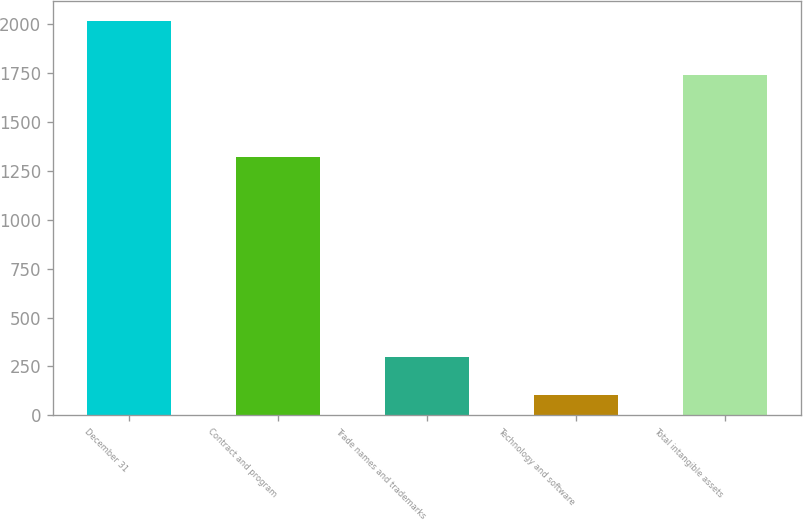Convert chart. <chart><loc_0><loc_0><loc_500><loc_500><bar_chart><fcel>December 31<fcel>Contract and program<fcel>Trade names and trademarks<fcel>Technology and software<fcel>Total intangible assets<nl><fcel>2017<fcel>1320<fcel>296.2<fcel>105<fcel>1739<nl></chart> 